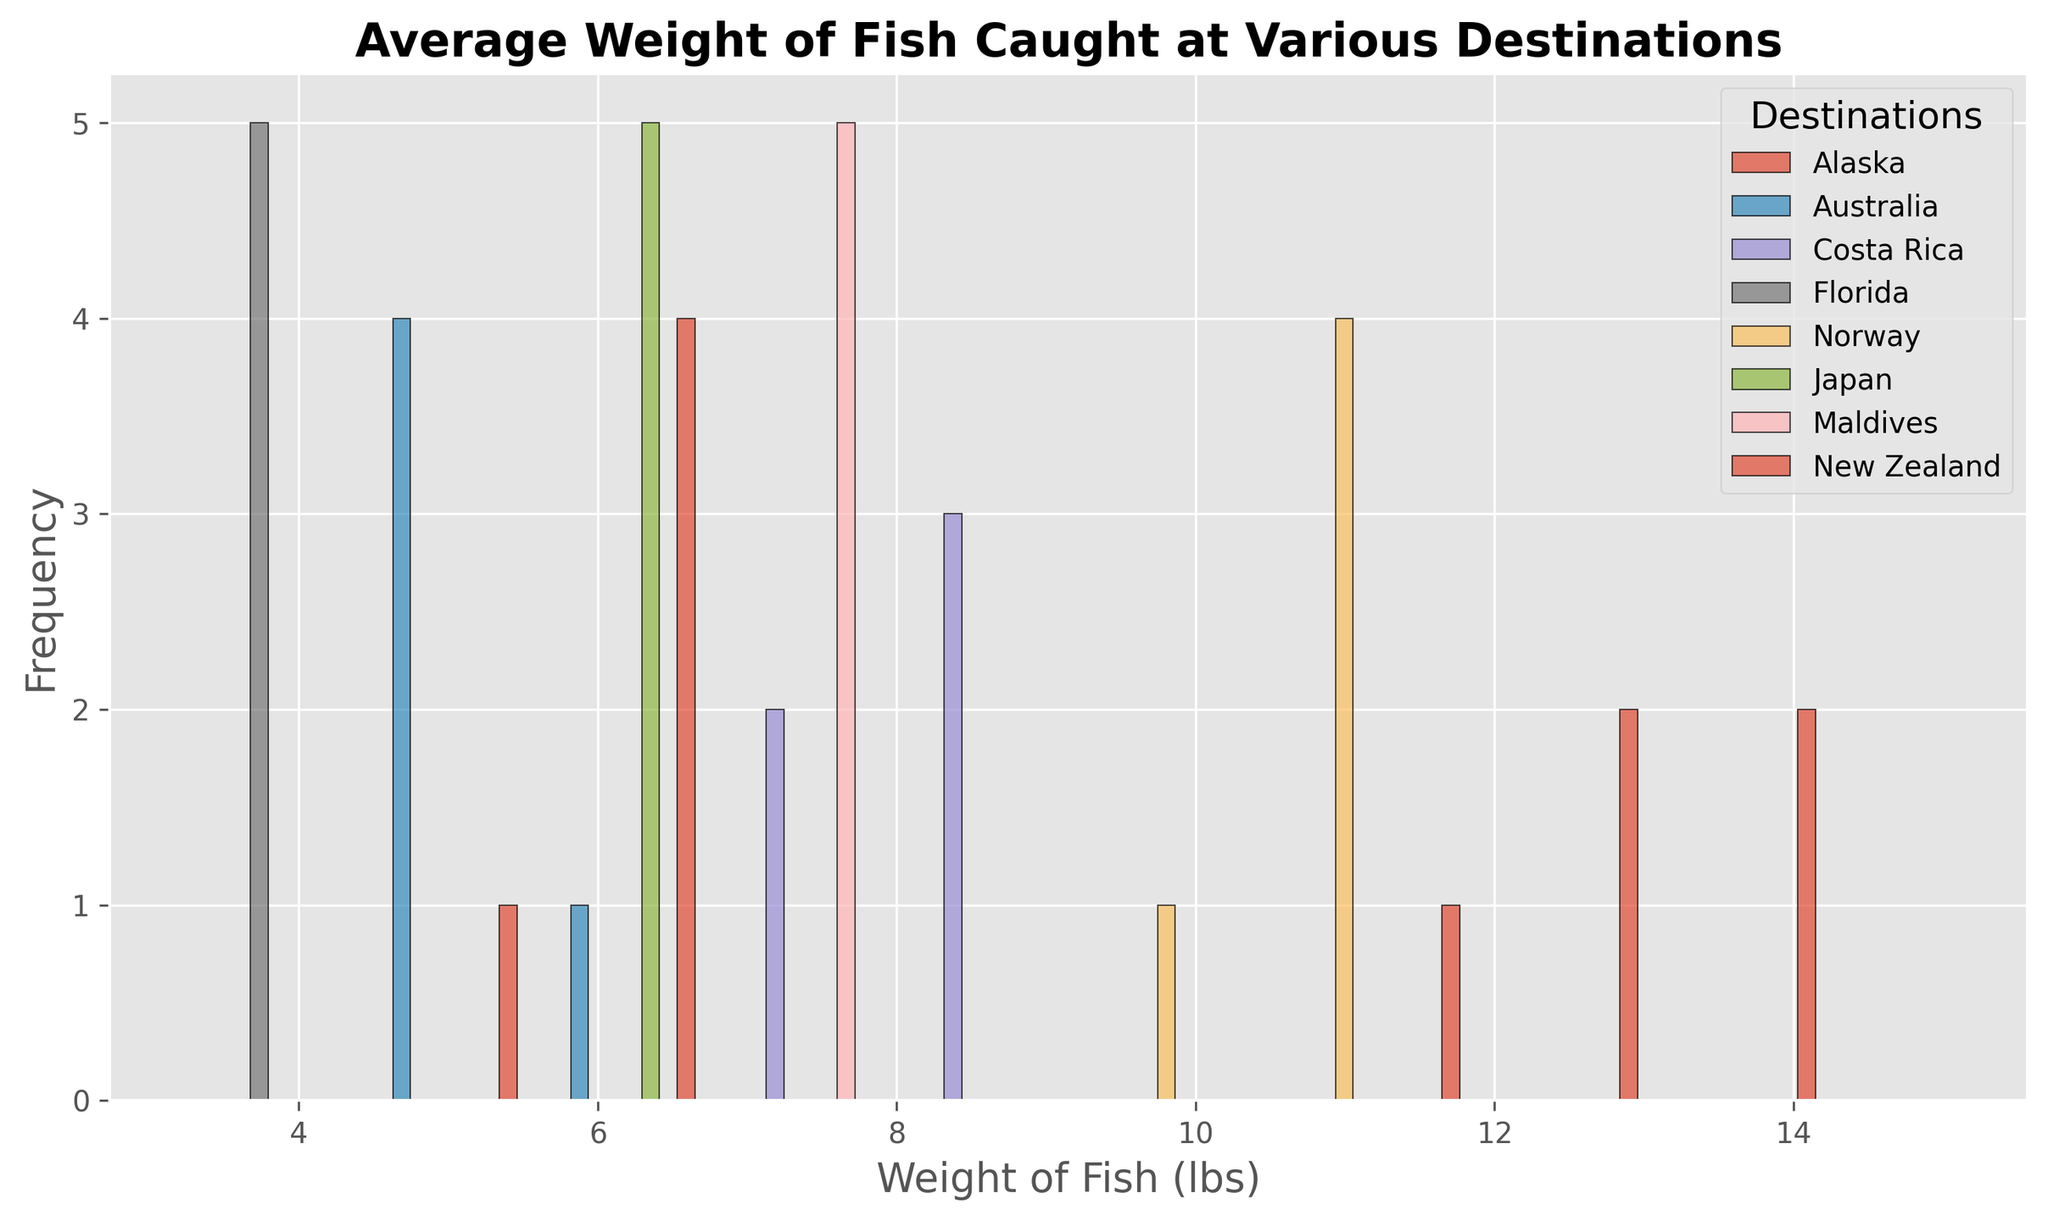What is the range of fish weights caught in Alaska? Refer to the histogram; the weights for Alaska range from the minimum to the maximum bins where there are frequencies noted for Alaska's data.
Answer: 12.4 to 15.1 How does the frequency of fish weighing between 3 to 5 lbs in Florida compare to that in Australia? Check the histogram and compare the bin heights for weights between 3 to 5 lbs for Florida and Australia. Florida shows consistent frequency in the 3-5 lbs range, while Australia also has considerable counts. Compare these visually.
Answer: Similar frequencies Which destination has the highest average fish weight? Examine the peaks and positions of the histograms for the various destinations. The destination with the highest peak in a higher weight range will have the highest average weight.
Answer: Alaska Is the average weight of fish in Japan greater or less than that in Costa Rica? Compare the positions of the histogram peaks for Japan and Costa Rica. The histogram peak for Costa Rica is in the 7-9 lbs range, while for Japan it's around the 6-7 lbs range.
Answer: Less What is the mode (most frequent weight) of fish caught in Norway? Look for the highest bar within the Norway histogram distribution to find the weight that appears most frequently.
Answer: 11 lbs Which destinations have overlapping weight ranges? Identify which histogram bars for different destinations overlap by observing the overlapping positions.
Answer: Australia and New Zealand How many destinations have their most frequent fish weights below 8 lbs? Count the histograms where the highest bars are positioned below the 8 lbs mark. Destinations below 8 lbs likely include Florida, Australia, Japan, and New Zealand.
Answer: Four What is the average weight range of fish caught in the Maldives? Refer to the histogram and observe the spread of bins for the Maldives to identify the range where most weights fall.
Answer: 6.9 to 7.6 Which destination shows the widest spread in fish weights? Identify the destination whose histogram bars extend across the largest range of weights by checking the widths of the histograms.
Answer: Alaska Is there a destination where the fish weight distribution is unimodal? Examine the histogram to find a destination with a single prominent peak, indicating a unimodal distribution.
Answer: Norway 